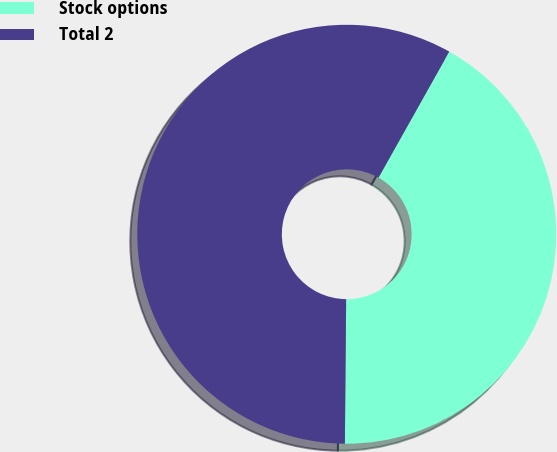Convert chart. <chart><loc_0><loc_0><loc_500><loc_500><pie_chart><fcel>Stock options<fcel>Total 2<nl><fcel>42.0%<fcel>58.0%<nl></chart> 